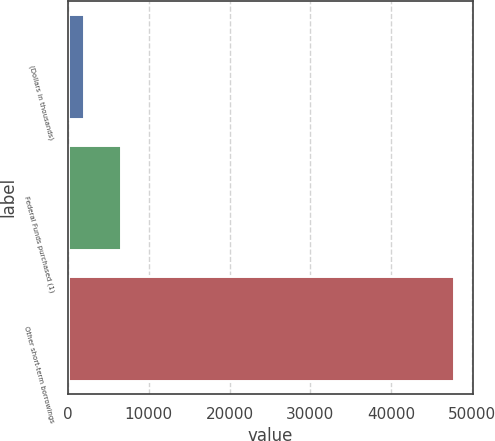Convert chart. <chart><loc_0><loc_0><loc_500><loc_500><bar_chart><fcel>(Dollars in thousands)<fcel>Federal Funds purchased (1)<fcel>Other short-term borrowings<nl><fcel>2010<fcel>6585.1<fcel>47761<nl></chart> 